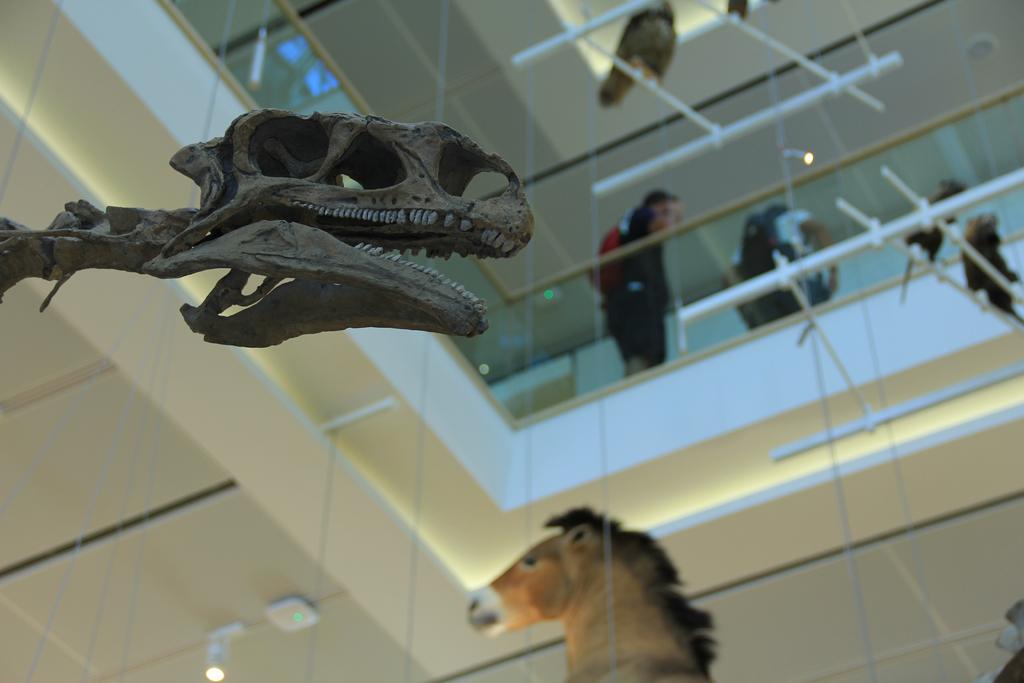Please provide a concise description of this image. This picture shows an inner view of a museum. Two persons are standing one, two. The first person wears the red color bag and second person wears a black color bag. Some threads are hanging. Some birds are there. One horse toy is there, one animal body is there. One light is there on the ceiling. 